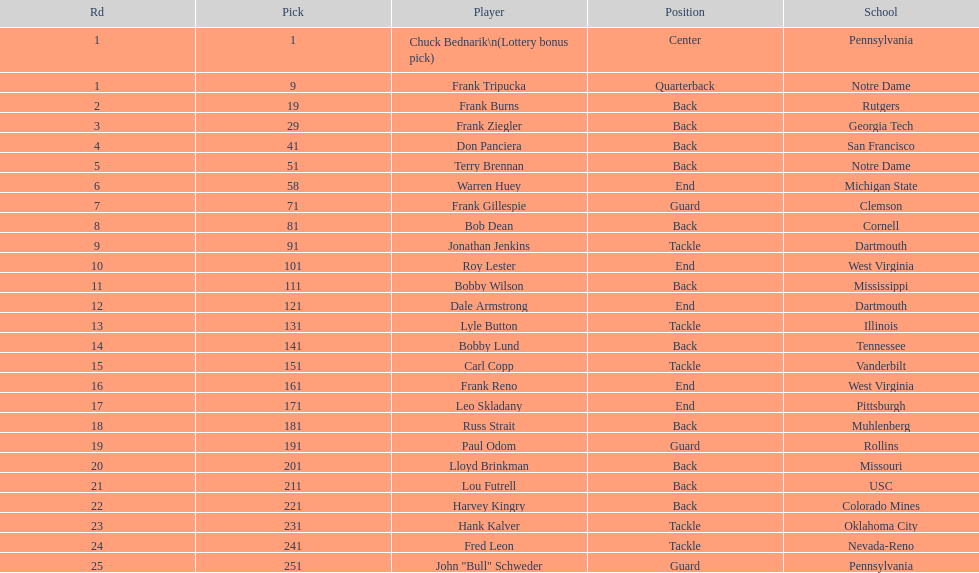What was the position that most of the players had? Back. 